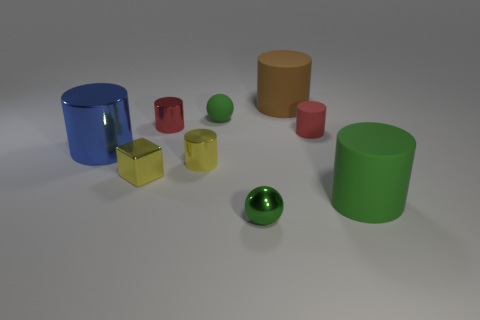There is a rubber thing that is the same color as the rubber ball; what size is it?
Offer a terse response. Large. Is the number of tiny yellow metal cylinders that are behind the large blue metal cylinder less than the number of red things that are on the left side of the shiny ball?
Ensure brevity in your answer.  Yes. Is there any other thing that is the same color as the tiny matte cylinder?
Offer a very short reply. Yes. There is a red metallic thing; what shape is it?
Your answer should be very brief. Cylinder. There is a big cylinder that is the same material as the large brown thing; what is its color?
Keep it short and to the point. Green. Is the number of large matte cylinders greater than the number of tiny cylinders?
Provide a succinct answer. No. Is there a red metallic sphere?
Ensure brevity in your answer.  No. There is a green rubber object right of the small ball in front of the yellow shiny cylinder; what shape is it?
Keep it short and to the point. Cylinder. How many objects are either yellow metal cylinders or things that are to the left of the tiny yellow metal cylinder?
Provide a short and direct response. 4. What color is the big cylinder on the left side of the thing in front of the big matte cylinder that is to the right of the big brown matte cylinder?
Offer a very short reply. Blue. 